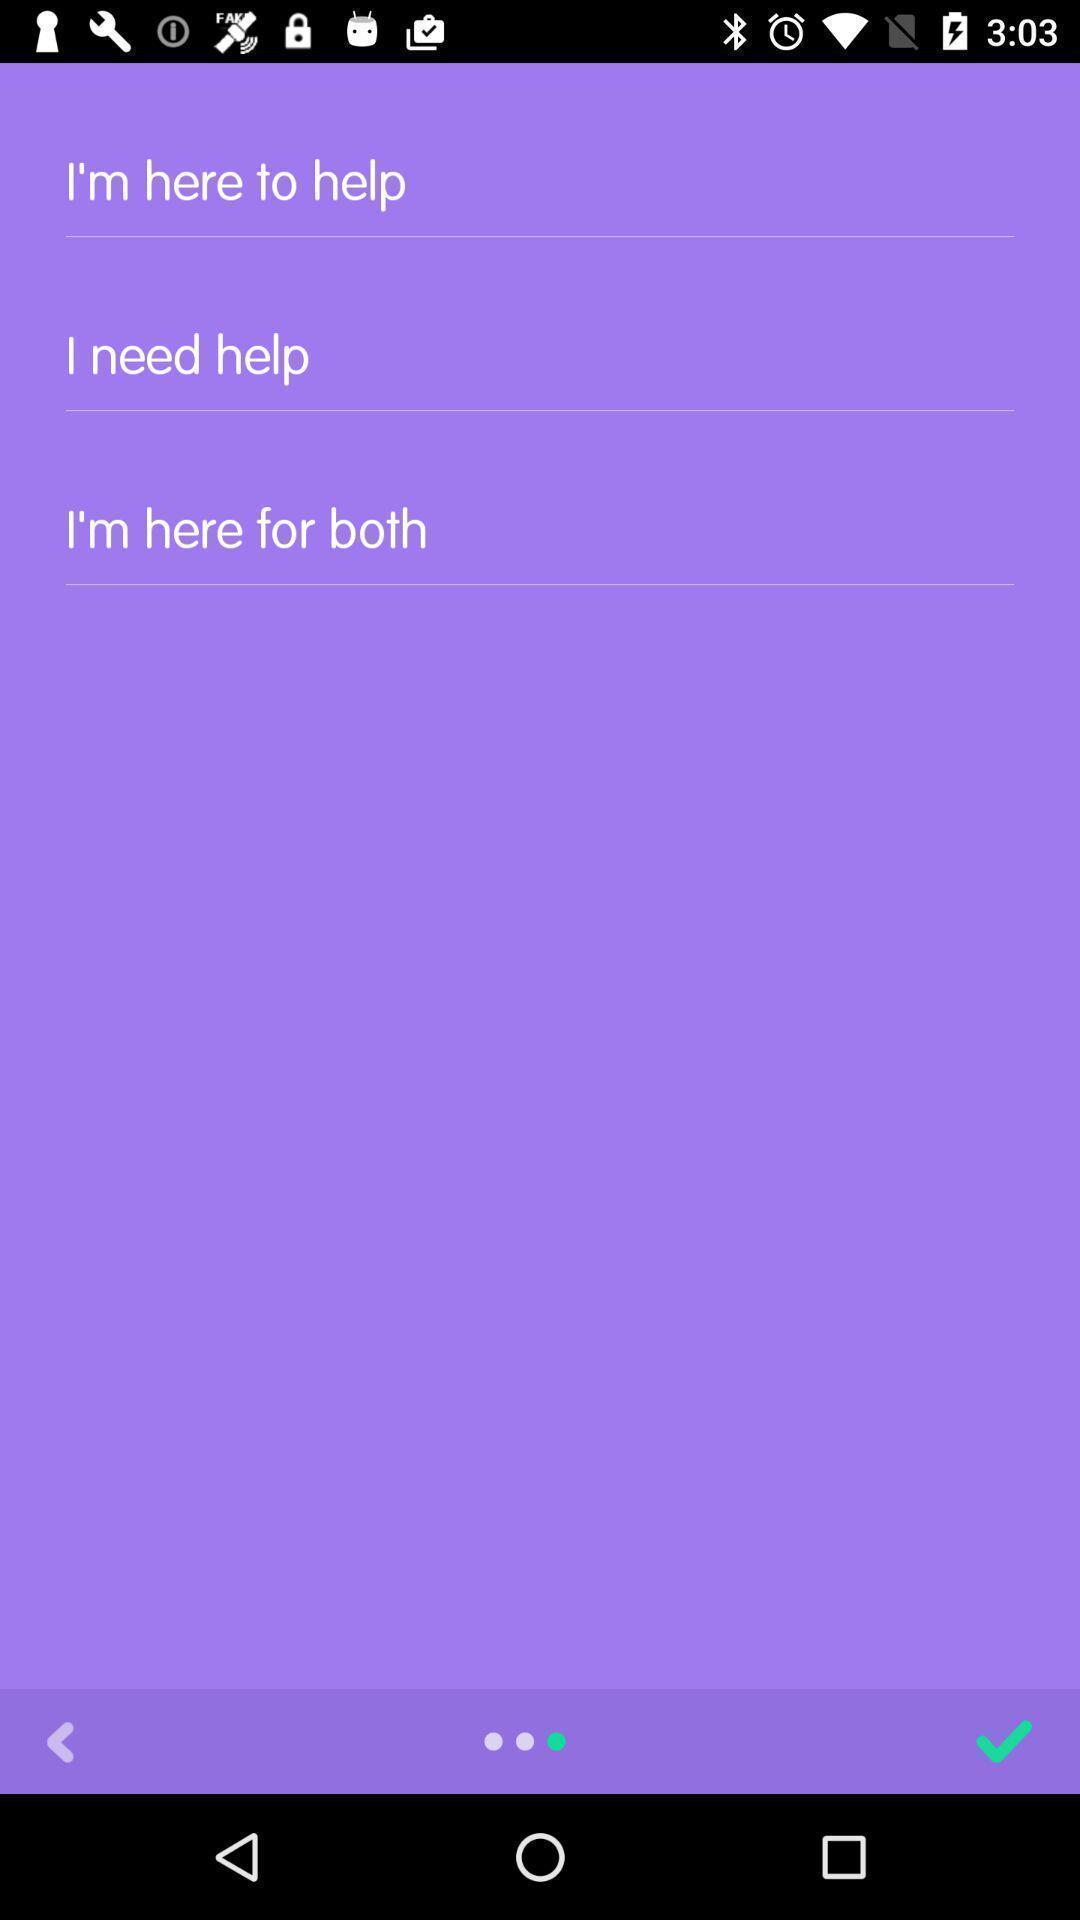Tell me what you see in this picture. Screen displaying different help options. 